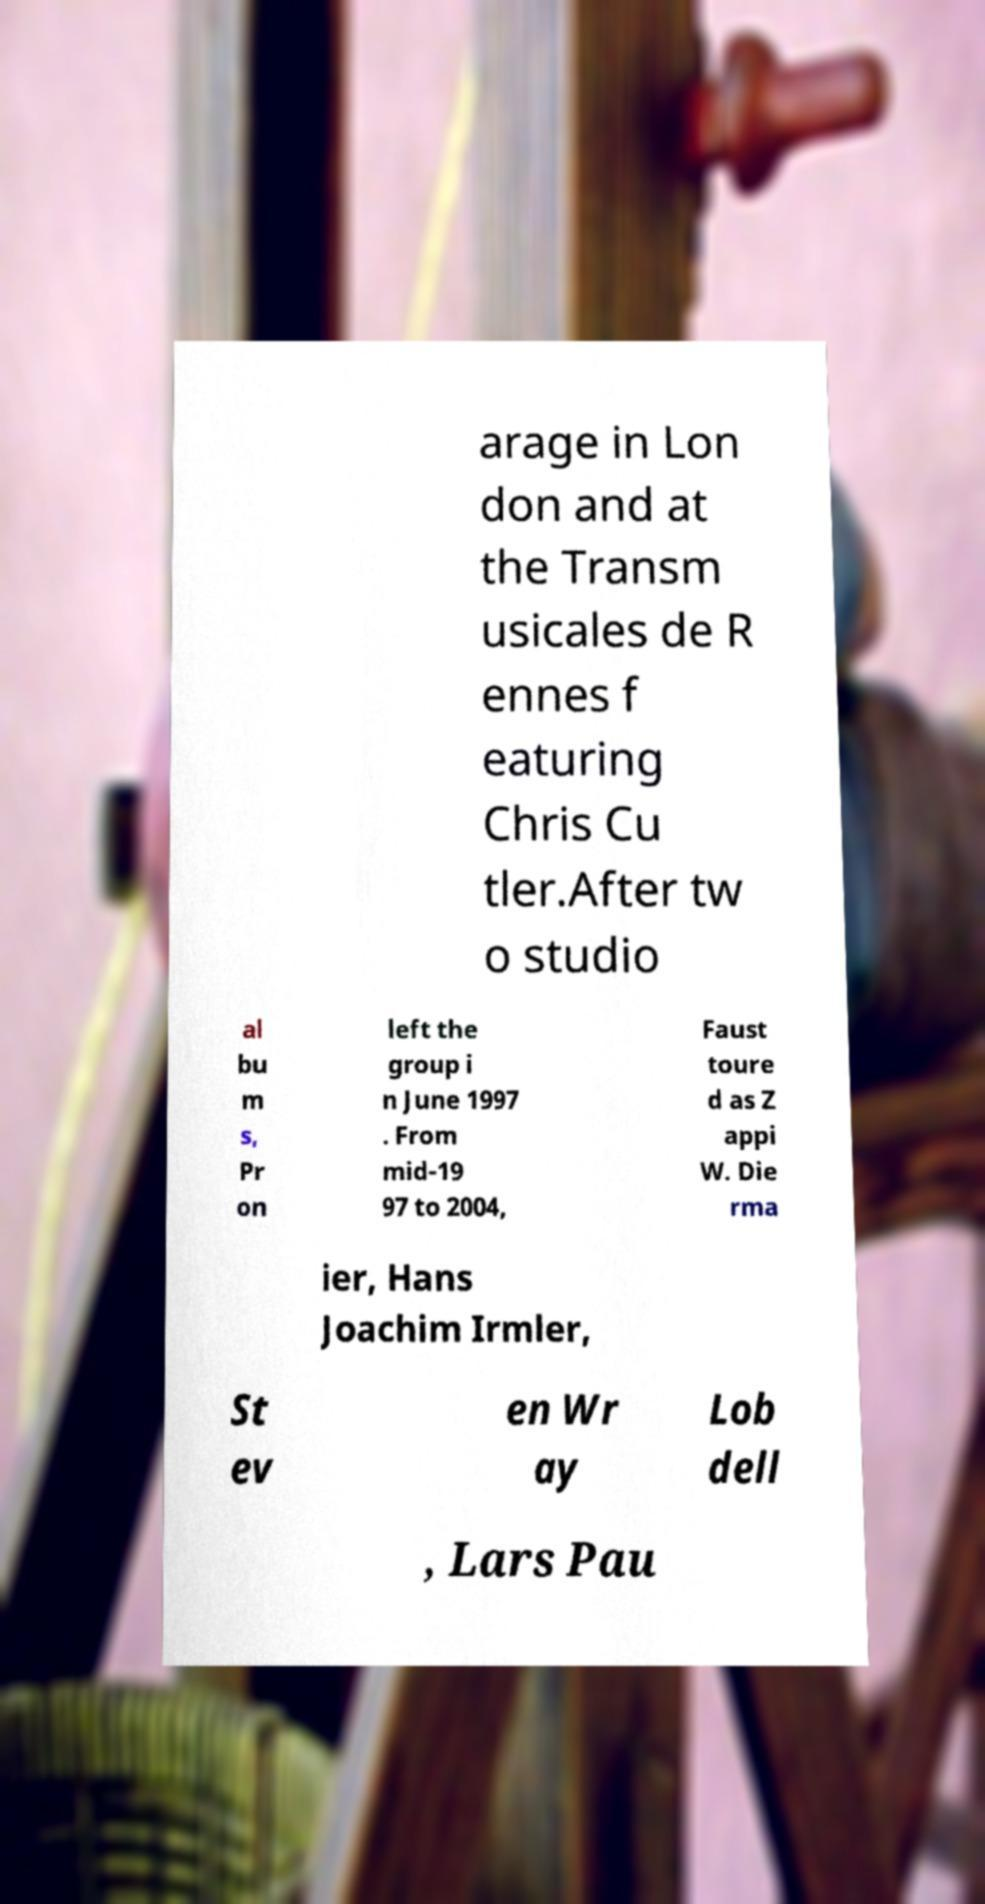Can you read and provide the text displayed in the image?This photo seems to have some interesting text. Can you extract and type it out for me? arage in Lon don and at the Transm usicales de R ennes f eaturing Chris Cu tler.After tw o studio al bu m s, Pr on left the group i n June 1997 . From mid-19 97 to 2004, Faust toure d as Z appi W. Die rma ier, Hans Joachim Irmler, St ev en Wr ay Lob dell , Lars Pau 